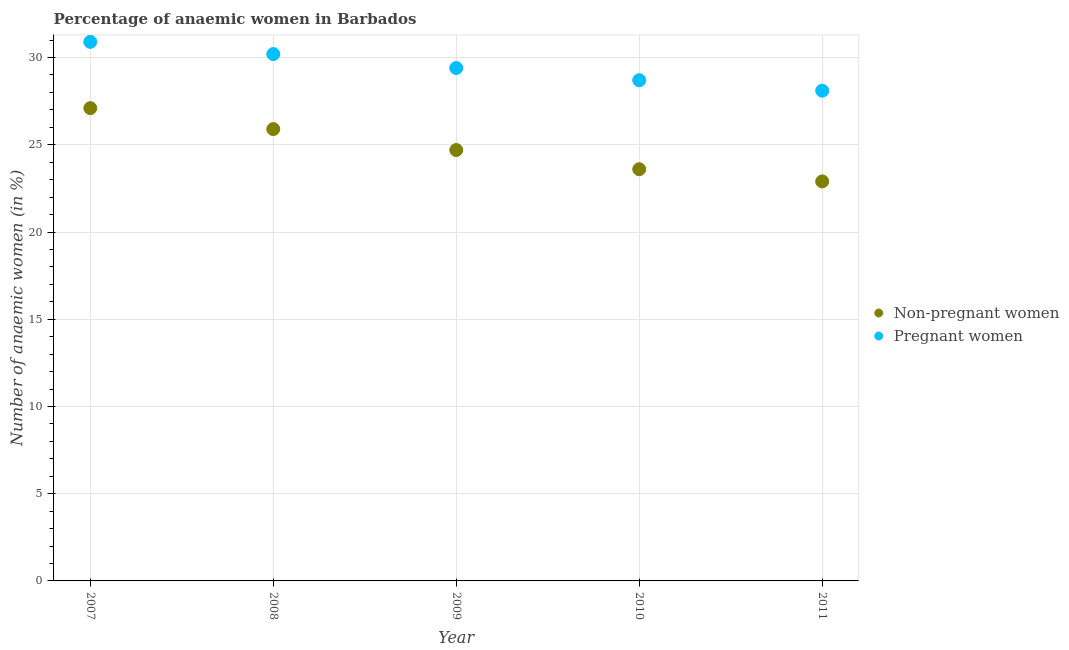How many different coloured dotlines are there?
Your answer should be compact. 2. Is the number of dotlines equal to the number of legend labels?
Make the answer very short. Yes. What is the percentage of non-pregnant anaemic women in 2007?
Keep it short and to the point. 27.1. Across all years, what is the maximum percentage of pregnant anaemic women?
Offer a very short reply. 30.9. Across all years, what is the minimum percentage of pregnant anaemic women?
Your answer should be compact. 28.1. What is the total percentage of pregnant anaemic women in the graph?
Your response must be concise. 147.3. What is the difference between the percentage of non-pregnant anaemic women in 2008 and that in 2010?
Your answer should be compact. 2.3. What is the difference between the percentage of pregnant anaemic women in 2007 and the percentage of non-pregnant anaemic women in 2009?
Provide a succinct answer. 6.2. What is the average percentage of pregnant anaemic women per year?
Keep it short and to the point. 29.46. In the year 2009, what is the difference between the percentage of non-pregnant anaemic women and percentage of pregnant anaemic women?
Your answer should be very brief. -4.7. In how many years, is the percentage of pregnant anaemic women greater than 3 %?
Ensure brevity in your answer.  5. What is the ratio of the percentage of non-pregnant anaemic women in 2007 to that in 2011?
Keep it short and to the point. 1.18. What is the difference between the highest and the second highest percentage of pregnant anaemic women?
Offer a very short reply. 0.7. What is the difference between the highest and the lowest percentage of pregnant anaemic women?
Your answer should be very brief. 2.8. In how many years, is the percentage of pregnant anaemic women greater than the average percentage of pregnant anaemic women taken over all years?
Your response must be concise. 2. Is the percentage of pregnant anaemic women strictly greater than the percentage of non-pregnant anaemic women over the years?
Offer a very short reply. Yes. Is the percentage of pregnant anaemic women strictly less than the percentage of non-pregnant anaemic women over the years?
Give a very brief answer. No. What is the difference between two consecutive major ticks on the Y-axis?
Your response must be concise. 5. Are the values on the major ticks of Y-axis written in scientific E-notation?
Offer a terse response. No. Does the graph contain any zero values?
Keep it short and to the point. No. Where does the legend appear in the graph?
Ensure brevity in your answer.  Center right. How many legend labels are there?
Offer a very short reply. 2. What is the title of the graph?
Offer a terse response. Percentage of anaemic women in Barbados. What is the label or title of the Y-axis?
Give a very brief answer. Number of anaemic women (in %). What is the Number of anaemic women (in %) in Non-pregnant women in 2007?
Give a very brief answer. 27.1. What is the Number of anaemic women (in %) of Pregnant women in 2007?
Make the answer very short. 30.9. What is the Number of anaemic women (in %) of Non-pregnant women in 2008?
Provide a short and direct response. 25.9. What is the Number of anaemic women (in %) in Pregnant women in 2008?
Offer a terse response. 30.2. What is the Number of anaemic women (in %) in Non-pregnant women in 2009?
Give a very brief answer. 24.7. What is the Number of anaemic women (in %) in Pregnant women in 2009?
Offer a very short reply. 29.4. What is the Number of anaemic women (in %) in Non-pregnant women in 2010?
Provide a short and direct response. 23.6. What is the Number of anaemic women (in %) of Pregnant women in 2010?
Your answer should be compact. 28.7. What is the Number of anaemic women (in %) in Non-pregnant women in 2011?
Your response must be concise. 22.9. What is the Number of anaemic women (in %) in Pregnant women in 2011?
Offer a terse response. 28.1. Across all years, what is the maximum Number of anaemic women (in %) in Non-pregnant women?
Give a very brief answer. 27.1. Across all years, what is the maximum Number of anaemic women (in %) of Pregnant women?
Ensure brevity in your answer.  30.9. Across all years, what is the minimum Number of anaemic women (in %) in Non-pregnant women?
Keep it short and to the point. 22.9. Across all years, what is the minimum Number of anaemic women (in %) in Pregnant women?
Your response must be concise. 28.1. What is the total Number of anaemic women (in %) of Non-pregnant women in the graph?
Offer a terse response. 124.2. What is the total Number of anaemic women (in %) of Pregnant women in the graph?
Give a very brief answer. 147.3. What is the difference between the Number of anaemic women (in %) of Pregnant women in 2007 and that in 2008?
Your answer should be very brief. 0.7. What is the difference between the Number of anaemic women (in %) of Non-pregnant women in 2007 and that in 2009?
Offer a terse response. 2.4. What is the difference between the Number of anaemic women (in %) in Pregnant women in 2007 and that in 2009?
Give a very brief answer. 1.5. What is the difference between the Number of anaemic women (in %) in Pregnant women in 2007 and that in 2010?
Your response must be concise. 2.2. What is the difference between the Number of anaemic women (in %) in Pregnant women in 2008 and that in 2009?
Provide a short and direct response. 0.8. What is the difference between the Number of anaemic women (in %) in Non-pregnant women in 2008 and that in 2010?
Your response must be concise. 2.3. What is the difference between the Number of anaemic women (in %) in Pregnant women in 2008 and that in 2011?
Give a very brief answer. 2.1. What is the difference between the Number of anaemic women (in %) of Non-pregnant women in 2009 and that in 2010?
Make the answer very short. 1.1. What is the difference between the Number of anaemic women (in %) in Pregnant women in 2009 and that in 2011?
Keep it short and to the point. 1.3. What is the difference between the Number of anaemic women (in %) of Pregnant women in 2010 and that in 2011?
Offer a very short reply. 0.6. What is the difference between the Number of anaemic women (in %) in Non-pregnant women in 2007 and the Number of anaemic women (in %) in Pregnant women in 2008?
Give a very brief answer. -3.1. What is the difference between the Number of anaemic women (in %) in Non-pregnant women in 2008 and the Number of anaemic women (in %) in Pregnant women in 2010?
Your answer should be very brief. -2.8. What is the difference between the Number of anaemic women (in %) in Non-pregnant women in 2008 and the Number of anaemic women (in %) in Pregnant women in 2011?
Your answer should be compact. -2.2. What is the difference between the Number of anaemic women (in %) of Non-pregnant women in 2010 and the Number of anaemic women (in %) of Pregnant women in 2011?
Give a very brief answer. -4.5. What is the average Number of anaemic women (in %) in Non-pregnant women per year?
Offer a very short reply. 24.84. What is the average Number of anaemic women (in %) in Pregnant women per year?
Your answer should be very brief. 29.46. In the year 2008, what is the difference between the Number of anaemic women (in %) in Non-pregnant women and Number of anaemic women (in %) in Pregnant women?
Offer a very short reply. -4.3. In the year 2010, what is the difference between the Number of anaemic women (in %) of Non-pregnant women and Number of anaemic women (in %) of Pregnant women?
Give a very brief answer. -5.1. What is the ratio of the Number of anaemic women (in %) of Non-pregnant women in 2007 to that in 2008?
Provide a succinct answer. 1.05. What is the ratio of the Number of anaemic women (in %) of Pregnant women in 2007 to that in 2008?
Make the answer very short. 1.02. What is the ratio of the Number of anaemic women (in %) of Non-pregnant women in 2007 to that in 2009?
Offer a very short reply. 1.1. What is the ratio of the Number of anaemic women (in %) of Pregnant women in 2007 to that in 2009?
Ensure brevity in your answer.  1.05. What is the ratio of the Number of anaemic women (in %) of Non-pregnant women in 2007 to that in 2010?
Your answer should be very brief. 1.15. What is the ratio of the Number of anaemic women (in %) of Pregnant women in 2007 to that in 2010?
Make the answer very short. 1.08. What is the ratio of the Number of anaemic women (in %) of Non-pregnant women in 2007 to that in 2011?
Provide a succinct answer. 1.18. What is the ratio of the Number of anaemic women (in %) in Pregnant women in 2007 to that in 2011?
Ensure brevity in your answer.  1.1. What is the ratio of the Number of anaemic women (in %) in Non-pregnant women in 2008 to that in 2009?
Your answer should be compact. 1.05. What is the ratio of the Number of anaemic women (in %) of Pregnant women in 2008 to that in 2009?
Offer a very short reply. 1.03. What is the ratio of the Number of anaemic women (in %) in Non-pregnant women in 2008 to that in 2010?
Your answer should be compact. 1.1. What is the ratio of the Number of anaemic women (in %) of Pregnant women in 2008 to that in 2010?
Provide a succinct answer. 1.05. What is the ratio of the Number of anaemic women (in %) of Non-pregnant women in 2008 to that in 2011?
Your answer should be very brief. 1.13. What is the ratio of the Number of anaemic women (in %) of Pregnant women in 2008 to that in 2011?
Offer a terse response. 1.07. What is the ratio of the Number of anaemic women (in %) of Non-pregnant women in 2009 to that in 2010?
Provide a succinct answer. 1.05. What is the ratio of the Number of anaemic women (in %) of Pregnant women in 2009 to that in 2010?
Keep it short and to the point. 1.02. What is the ratio of the Number of anaemic women (in %) of Non-pregnant women in 2009 to that in 2011?
Provide a succinct answer. 1.08. What is the ratio of the Number of anaemic women (in %) of Pregnant women in 2009 to that in 2011?
Offer a very short reply. 1.05. What is the ratio of the Number of anaemic women (in %) in Non-pregnant women in 2010 to that in 2011?
Keep it short and to the point. 1.03. What is the ratio of the Number of anaemic women (in %) of Pregnant women in 2010 to that in 2011?
Provide a succinct answer. 1.02. 